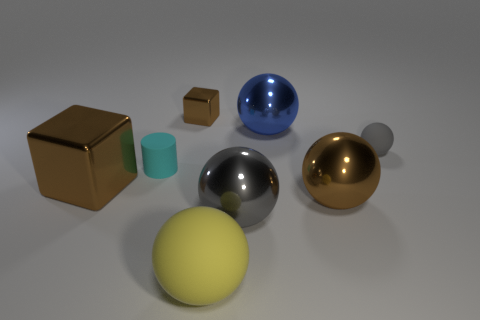Subtract all yellow balls. How many balls are left? 4 Subtract all big blue metal spheres. How many spheres are left? 4 Subtract 2 balls. How many balls are left? 3 Subtract all green spheres. Subtract all cyan cubes. How many spheres are left? 5 Add 1 rubber cylinders. How many objects exist? 9 Subtract all blocks. How many objects are left? 6 Add 3 rubber balls. How many rubber balls are left? 5 Add 6 large brown balls. How many large brown balls exist? 7 Subtract 0 green cylinders. How many objects are left? 8 Subtract all tiny cyan matte cylinders. Subtract all brown metal objects. How many objects are left? 4 